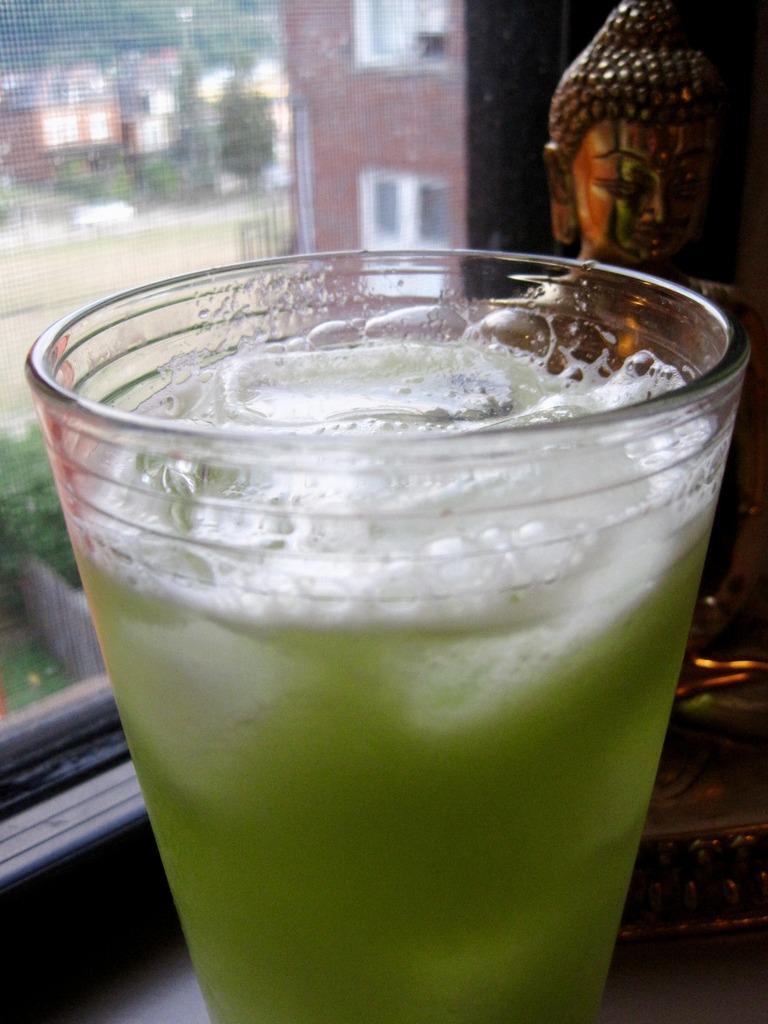In one or two sentences, can you explain what this image depicts? In this image I can see a glass, in the glass I can see some liquid in green color. Background I can see a glass window and building in brown color. 